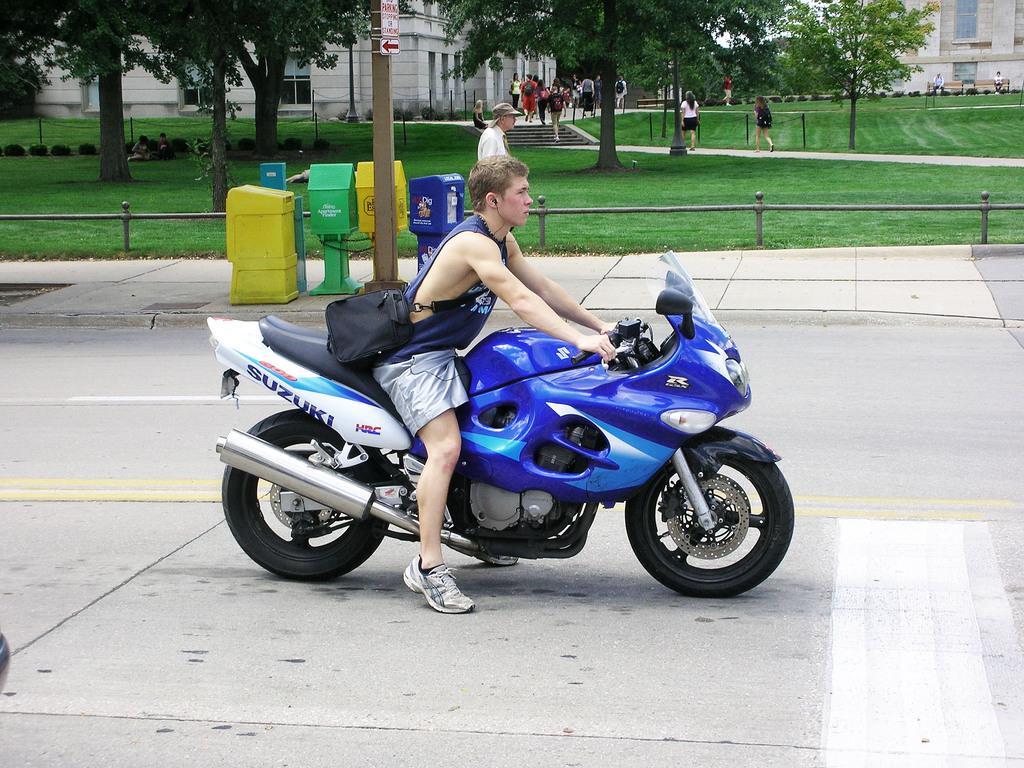Could you give a brief overview of what you see in this image? There is a man sitting on a bike on the road holding a bag across his shoulders. In the background there some post boxes and a pole. There are some trees and buildings here. 